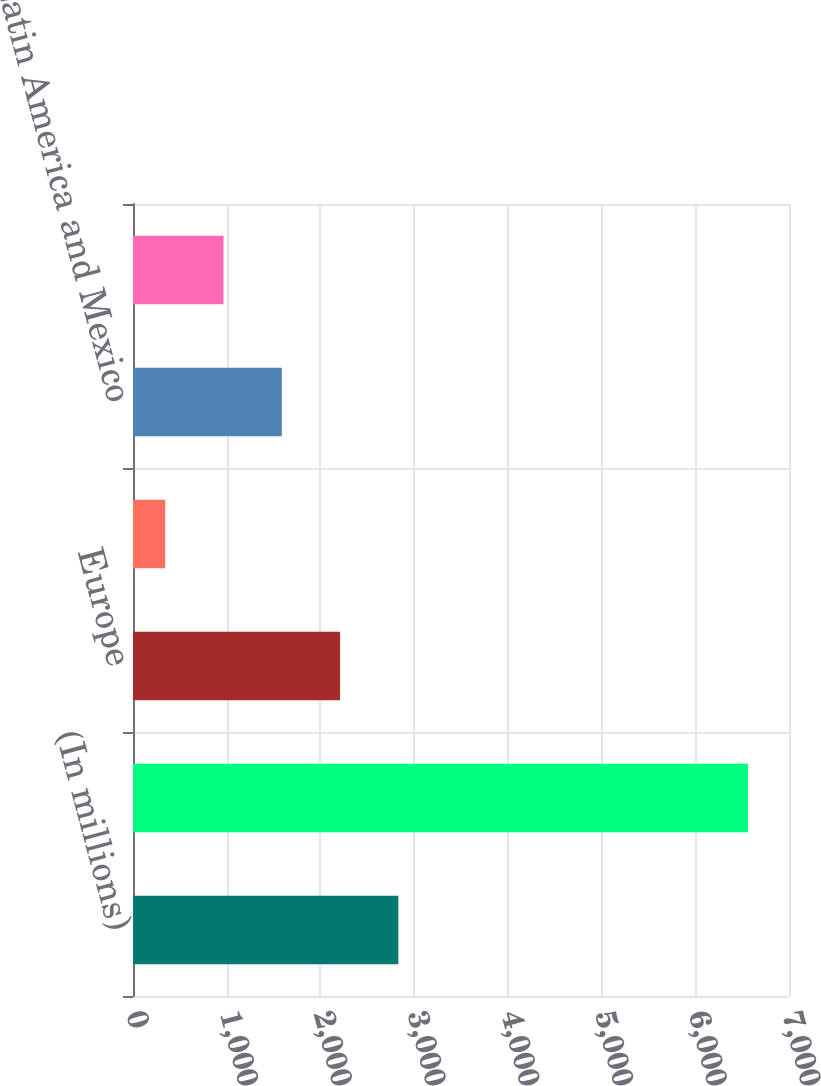Convert chart. <chart><loc_0><loc_0><loc_500><loc_500><bar_chart><fcel>(In millions)<fcel>United States<fcel>Europe<fcel>Canada<fcel>Latin America and Mexico<fcel>Asia and Australia<nl><fcel>2831.6<fcel>6563<fcel>2209.7<fcel>344<fcel>1587.8<fcel>965.9<nl></chart> 